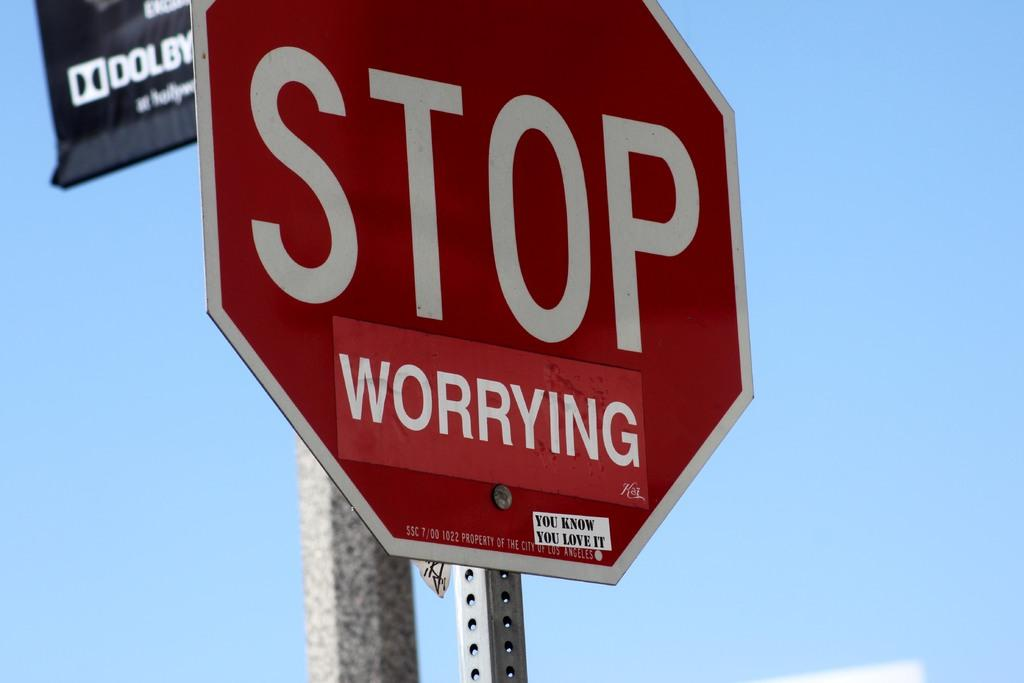<image>
Offer a succinct explanation of the picture presented. A red stop sign with a sticker under stop that says worrying. 